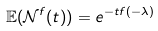Convert formula to latex. <formula><loc_0><loc_0><loc_500><loc_500>\mathbb { E } ( \mathcal { N } ^ { f } ( t ) ) = e ^ { - t f ( - \lambda ) }</formula> 